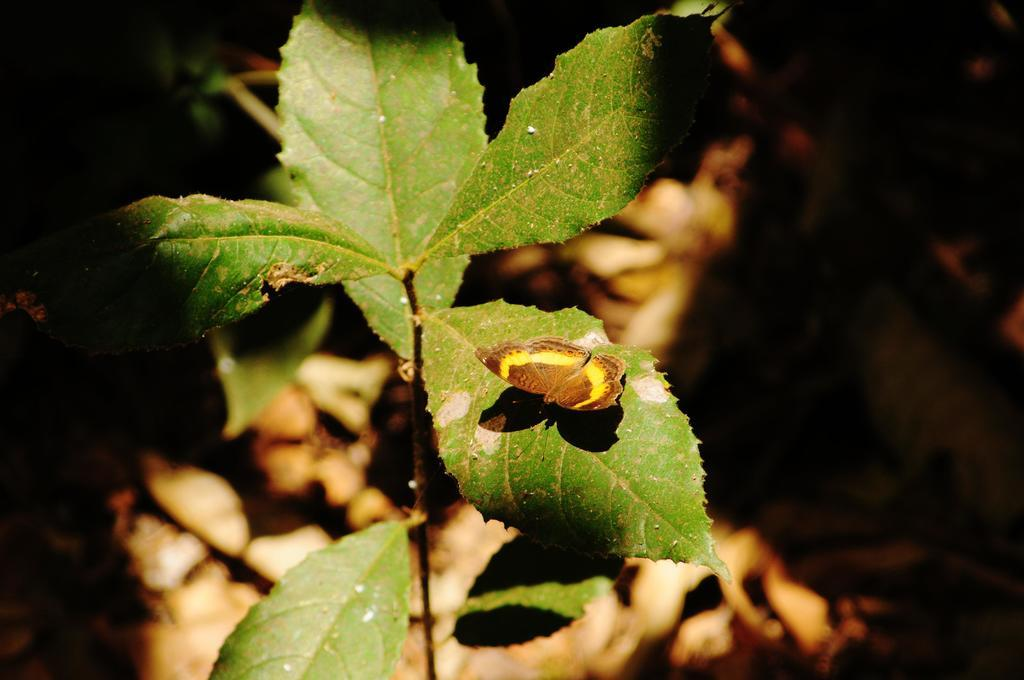What type of plant can be seen in the image? There is a plant with green leaves in the image. Can you describe the condition of the plant's leaves? The leaves of the plant have dust on them. What can be observed about the background of the image? The background of the image is blurred. What type of wealth is displayed on the throne in the image? There is no throne or wealth present in the image; it features a plant with green leaves and dusty leaves. What form does the plant take in the image? The plant in the image has green leaves and dust on them, but there is no mention of a specific form or shape. 